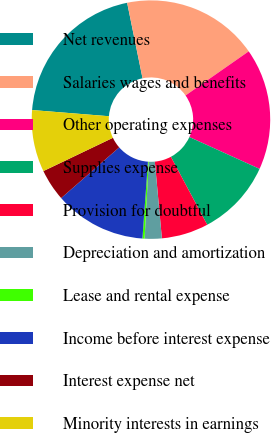Convert chart. <chart><loc_0><loc_0><loc_500><loc_500><pie_chart><fcel>Net revenues<fcel>Salaries wages and benefits<fcel>Other operating expenses<fcel>Supplies expense<fcel>Provision for doubtful<fcel>Depreciation and amortization<fcel>Lease and rental expense<fcel>Income before interest expense<fcel>Interest expense net<fcel>Minority interests in earnings<nl><fcel>20.52%<fcel>18.5%<fcel>16.48%<fcel>10.4%<fcel>6.36%<fcel>2.31%<fcel>0.29%<fcel>12.43%<fcel>4.33%<fcel>8.38%<nl></chart> 